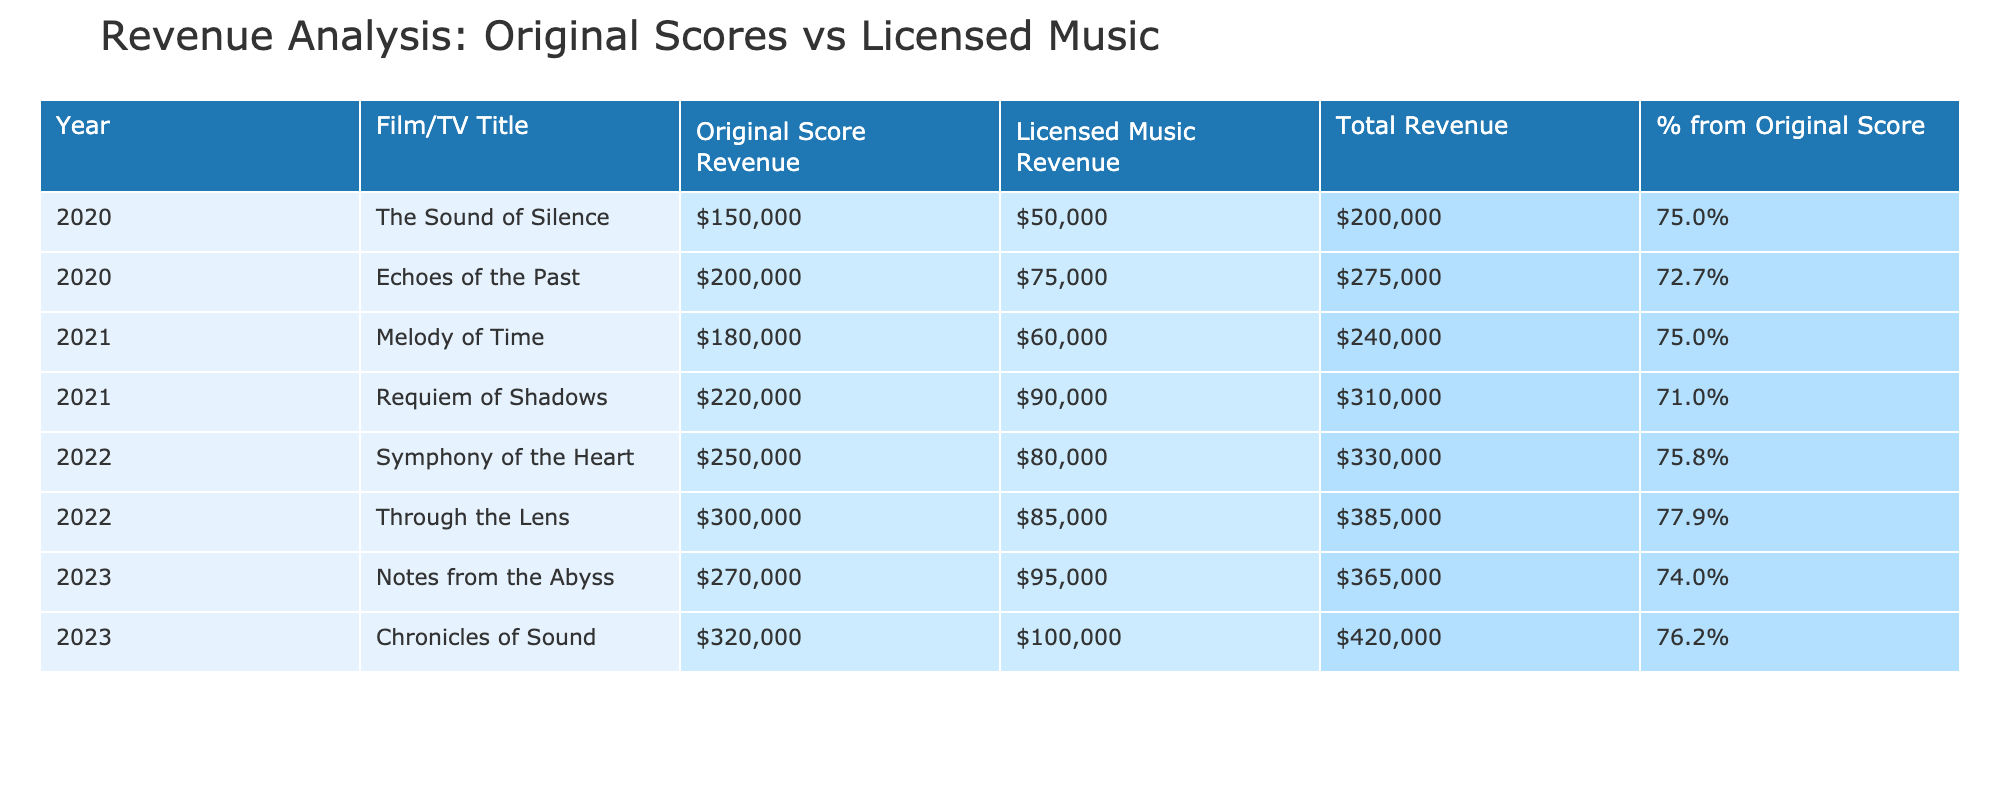What is the total revenue generated from original scores in 2023? The total revenue from original scores in 2023 is listed as 320,000 USD in the table.
Answer: 320000 Which film generated the highest revenue from licensing pre-existing music? By examining the table, "Chronicles of Sound" has the highest licensing revenue of 100,000 USD among all films listed.
Answer: Chronicles of Sound What is the average revenue from original scores across all years? First, we sum the revenue from original scores: (150000 + 200000 + 180000 + 220000 + 250000 + 300000 + 270000 + 320000) = 1890000 USD. There are 8 films, so the average is 1890000 / 8 = 236250 USD.
Answer: 236250 Did "Echoes of the Past" generate more revenue from original scores than "Melody of Time"? Comparing the two, "Echoes of the Past" had a revenue of 200,000 USD from original scores, while "Melody of Time" had 180,000 USD. Thus, "Echoes of the Past" generated more.
Answer: Yes What is the percentage of revenue from original scores for "Symphony of the Heart"? For "Symphony of the Heart," the revenue from original scores is 250,000 USD and total revenue is 250,000 + 80,000 = 330,000 USD. The percentage from original scores is (250,000 / 330,000) * 100 = 75.76%.
Answer: 75.8% How does the total revenue from all original scores compare to that of licensing music in 2020? The total revenue from original scores in 2020 is 150,000 USD while revenue from licensing is 50,000 USD. The original score revenue is three times higher than that of licensing.
Answer: Original scores were higher Which year showed the largest increase in revenue from original scores as compared to the previous year? Comparing the revenue from original scores year on year, the increase from 2021 (180,000) to 2022 (250,000) indicates the largest rise. The difference is 250,000 - 180,000 = 70,000 USD.
Answer: 2022 What was the total revenue from all films in 2021? The total revenue for films in 2021 includes the original score revenue of 180,000 USD and licensing revenue of 60,000 USD, totaling 240,000 USD.
Answer: 240000 